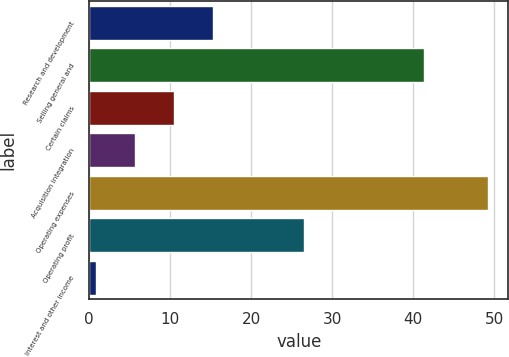Convert chart to OTSL. <chart><loc_0><loc_0><loc_500><loc_500><bar_chart><fcel>Research and development<fcel>Selling general and<fcel>Certain claims<fcel>Acquisition integration<fcel>Operating expenses<fcel>Operating profit<fcel>Interest and other income<nl><fcel>15.35<fcel>41.3<fcel>10.5<fcel>5.65<fcel>49.3<fcel>26.5<fcel>0.8<nl></chart> 